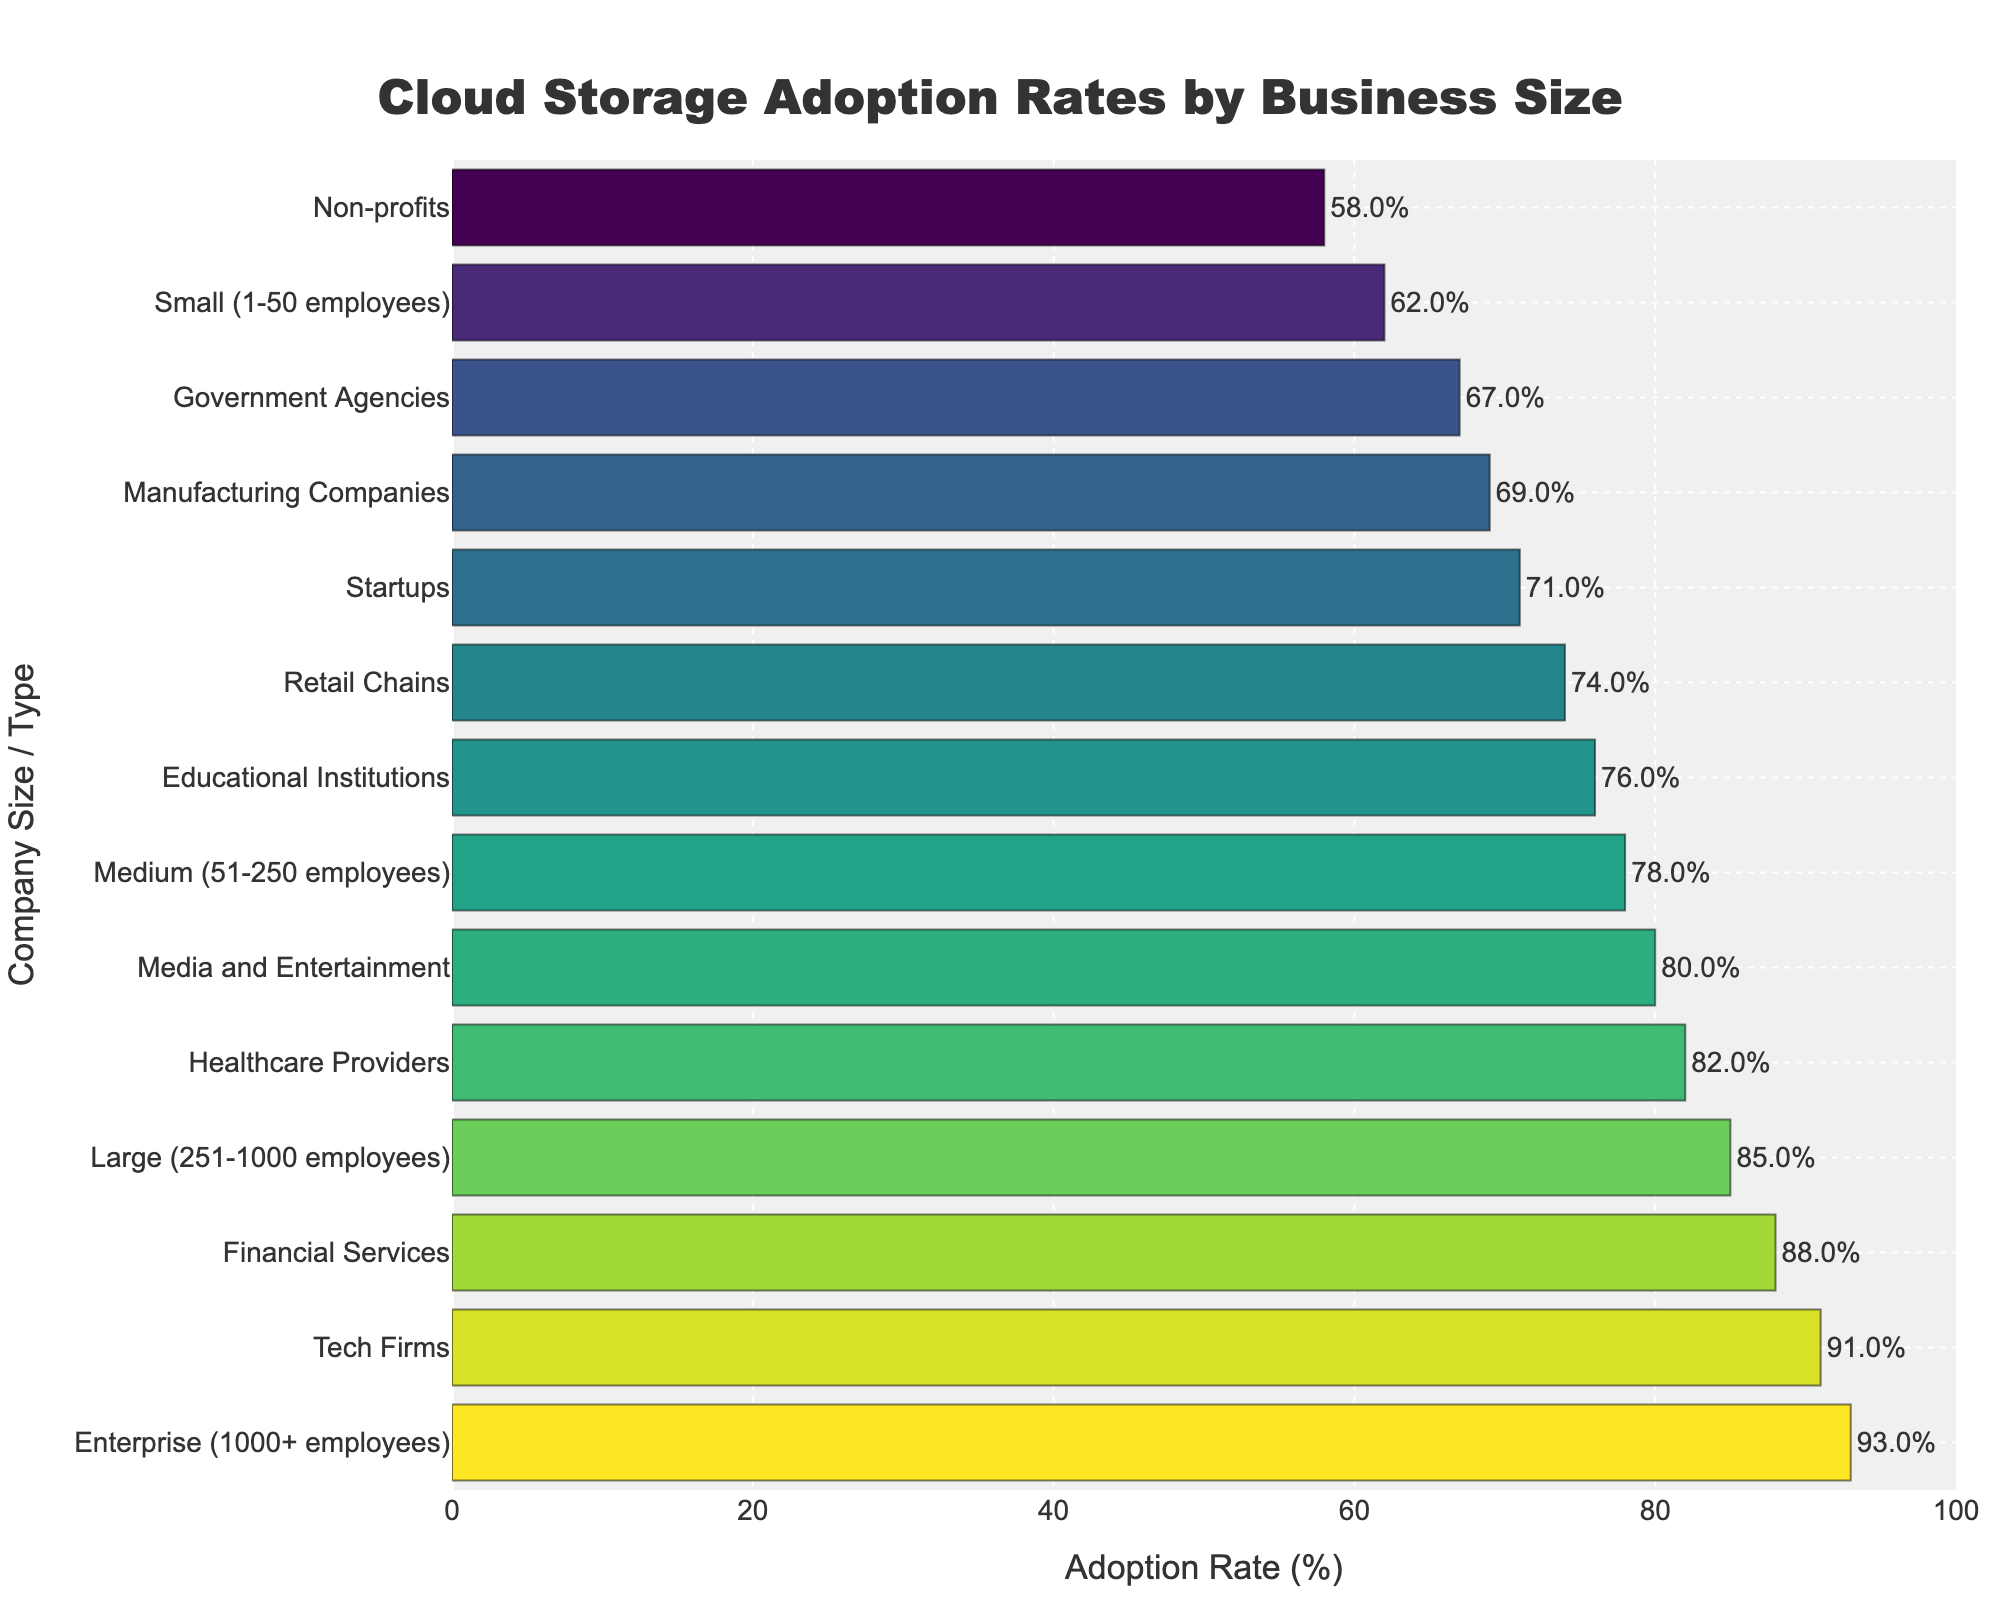Which business size has the highest cloud storage adoption rate? Look for the longest bar in the graph. The business size with the highest adoption rate should be the Enterprise category.
Answer: Enterprise What is the difference in cloud storage adoption rates between Tech Firms and Retail Chains? Find the adoption rates for both Tech Firms (91%) and Retail Chains (74%), then subtract the smaller from the larger. 91% - 74% = 17%
Answer: 17% What is the total cloud storage adoption rate for Small, Medium, and Large companies combined? Sum the adoption rates of Small (62%), Medium (78%), and Large (85%) companies. 62% + 78% + 85% = 225%
Answer: 225% Which business sizes have adoption rates greater than 80%? Identify the bars longer than 80%: Large (85%), Enterprise (93%), Healthcare Providers (82%), Tech Firms (91%), and Financial Services (88%)
Answer: Large, Enterprise, Healthcare Providers, Tech Firms, Financial Services What is the average cloud storage adoption rate for educational institutions, government agencies, and healthcare providers? Add the adoption rates for educational institutions (76%), government agencies (67%), and healthcare providers (82%), then divide by 3. (76% + 67% + 82%) / 3 = 75%
Answer: 75% Which business size types are represented with colors close to green on the colorscale? Look for the bars that visually appear close to green on the colorscale: Government Agencies (67%), Manufacturing Companies (69%), and Educational Institutions (76%)
Answer: Government Agencies, Manufacturing Companies, Educational Institutions How much higher is the cloud storage adoption rate for financial services than for media and entertainment? Find the rates for financial services (88%) and media and entertainment (80%), then subtract the smaller from the larger. 88% - 80% = 8%
Answer: 8% Rank the adoption rates for Small businesses, Startups, and Non-profits in ascending order. Find the adoption rates and order them: Non-profits (58%), Small (62%), and Startups (71%). So, Non-profits < Small < Startups.
Answer: Non-profits, Small, Startups Calculate the median adoption rate of all business sizes. Order all adoption rates: [58, 62, 67, 69, 71, 74, 76, 78, 80, 82, 85, 88, 91, 93]. The median is the average of the 7th and 8th terms: (76 + 78) / 2 = 77%.
Answer: 77% 